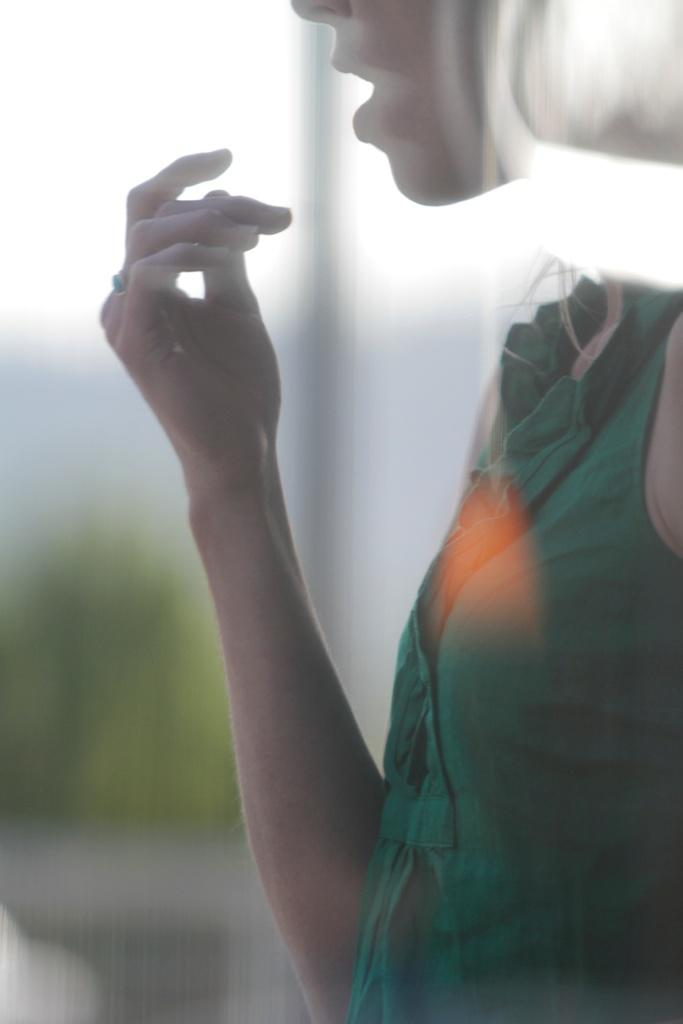Who is the main subject in the image? There is a girl in the middle of the image. What is the girl doing with her hand? The girl has raised her hand. Can you describe the background of the image? The background of the image appears blurry. Where are the girl's friends in the image? There is no mention of friends in the image, so we cannot determine their location. 